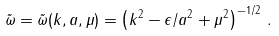<formula> <loc_0><loc_0><loc_500><loc_500>\tilde { \omega } = \tilde { \omega } ( k , a , \mu ) = \left ( k ^ { 2 } - { \epsilon / a ^ { 2 } } + \mu ^ { 2 } \right ) ^ { - 1 / 2 } \, .</formula> 